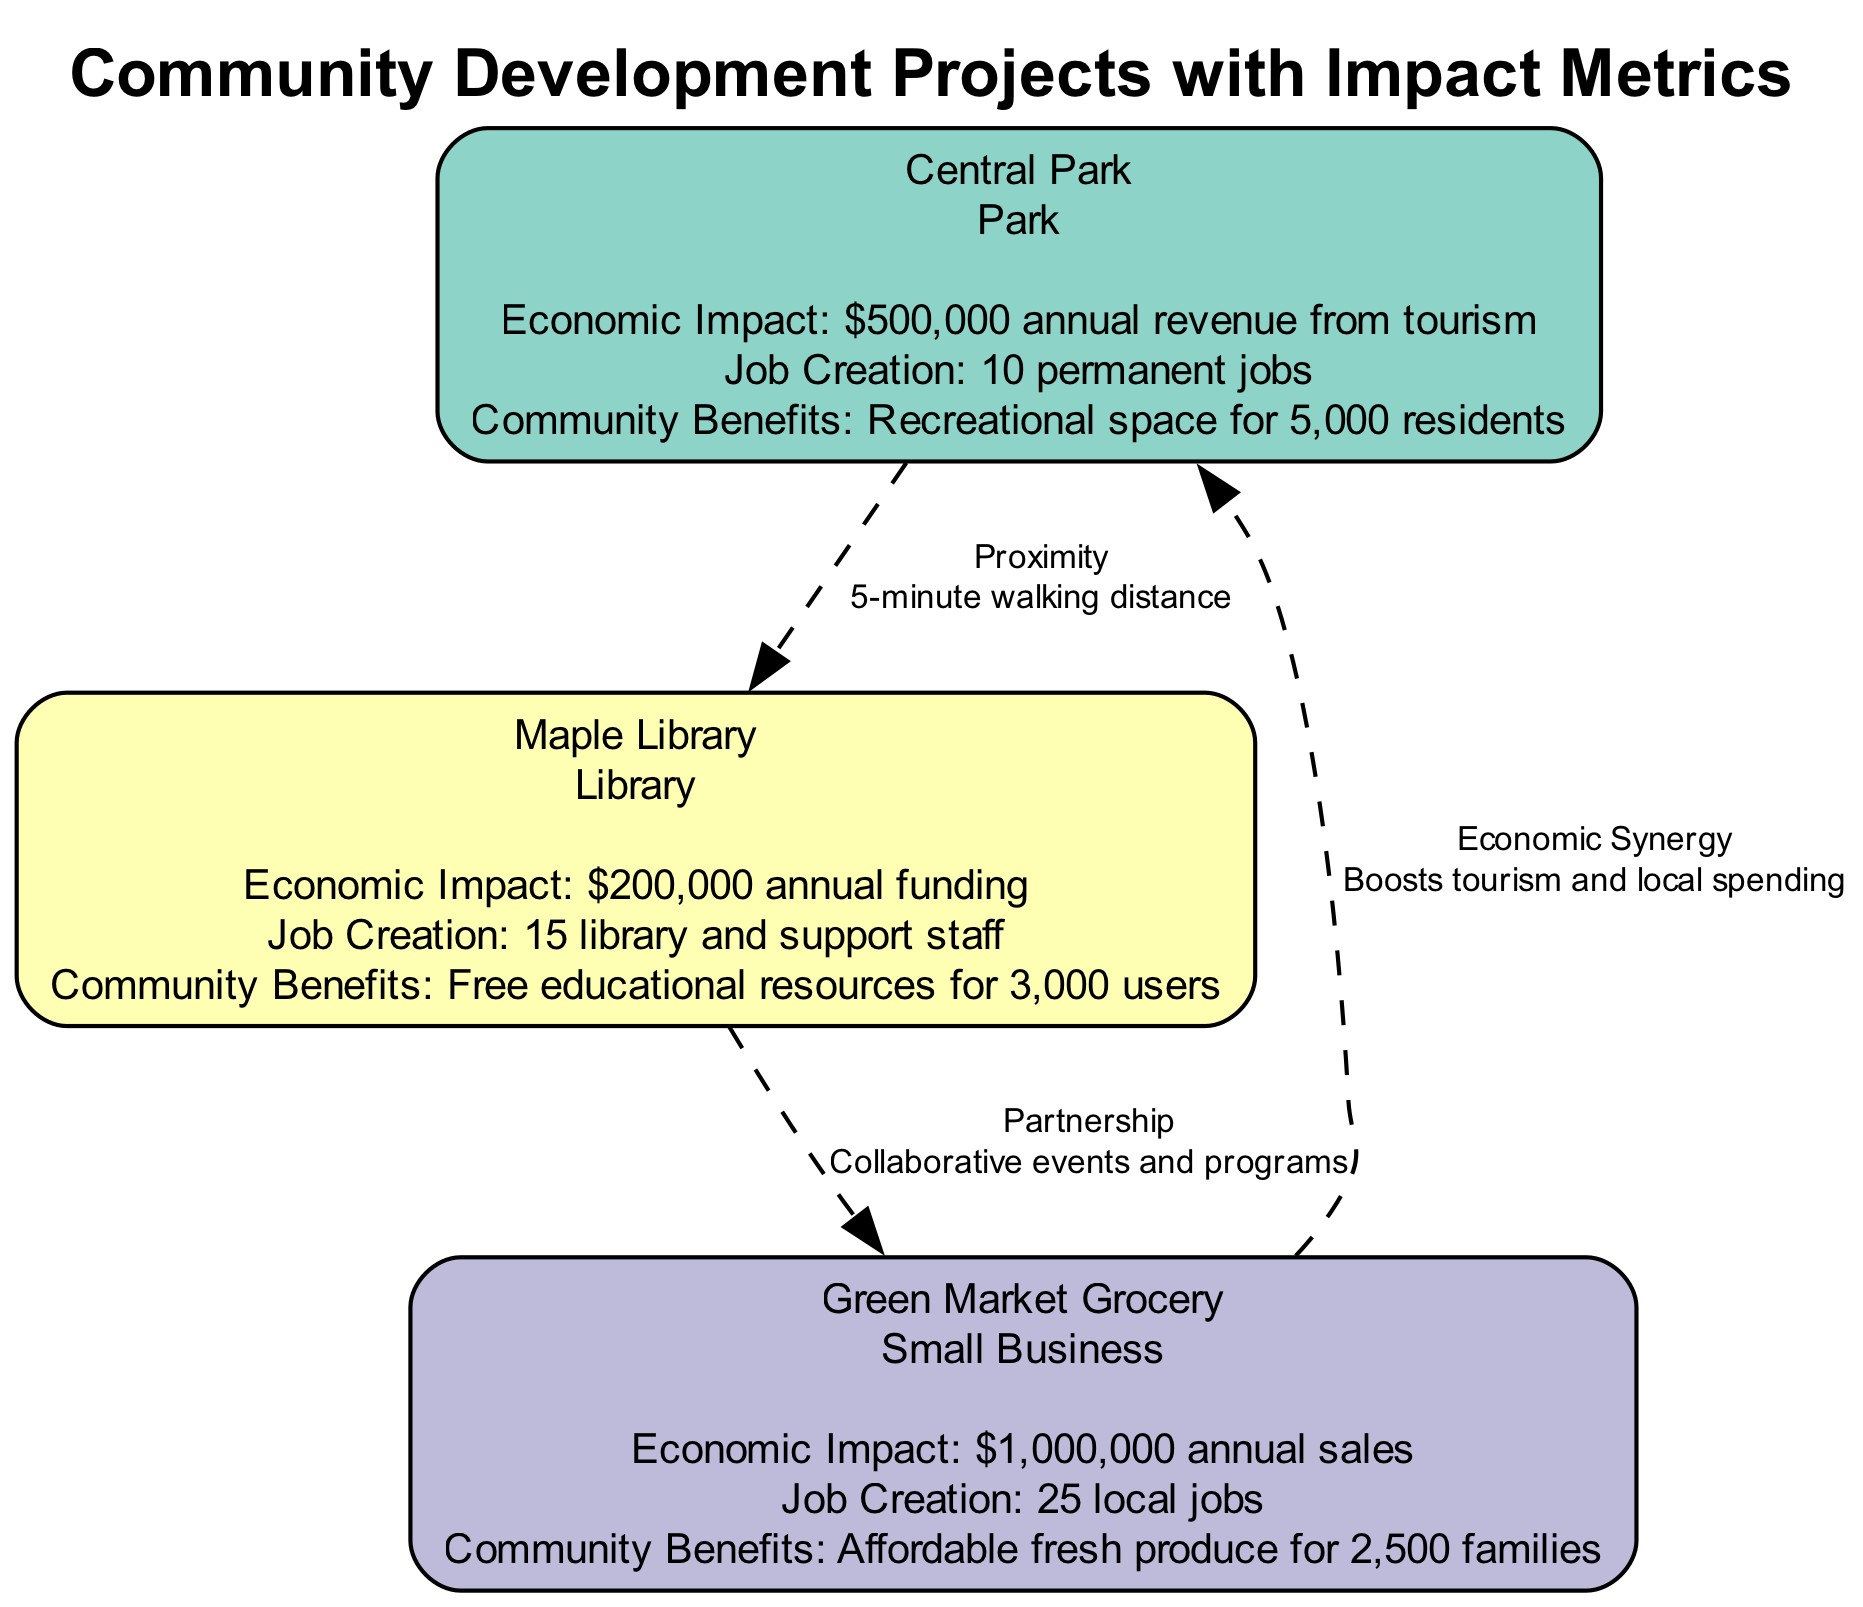What is the economic impact of Central Park? The economic impact of Central Park is directly stated in its metrics, which indicates an annual revenue of $500,000 from tourism.
Answer: $500,000 annual revenue from tourism How many permanent jobs does Maple Library create? The number of jobs created by Maple Library is mentioned in its metrics, which states that it creates 15 library and support staff jobs.
Answer: 15 library and support staff What is the relationship between the Park and the Library? The diagram specifies a proximity relationship between these two entities, with an explanation that they are within a 5-minute walking distance.
Answer: Proximity How many jobs are created by Green Market Grocery? Green Market Grocery's metrics show the creation of 25 local jobs, which is directly referenced in the node's information.
Answer: 25 local jobs Which community development project provides free educational resources? The community development project that provides free educational resources is Maple Library, as indicated in its community benefits metric.
Answer: Maple Library What is the total number of nodes in the diagram? The total number of nodes in the diagram can be determined by counting each listed entity: Central Park, Maple Library, and Green Market Grocery, which totals three.
Answer: 3 What is the relationship type between the Library and the Small Business? The relationship type between the Library and the Small Business is identified as a partnership, and the explanation specifies it involves collaborative events and programs.
Answer: Partnership How many families benefit from the fresh produce at Green Market Grocery? The community benefits metric for Green Market Grocery specifies that it offers affordable fresh produce to 2,500 families.
Answer: 2,500 families Which node has the highest annual sales? Based on the economic impact metrics, Green Market Grocery has the highest annual sales of $1,000,000, as explicitly stated in its information.
Answer: $1,000,000 annual sales 